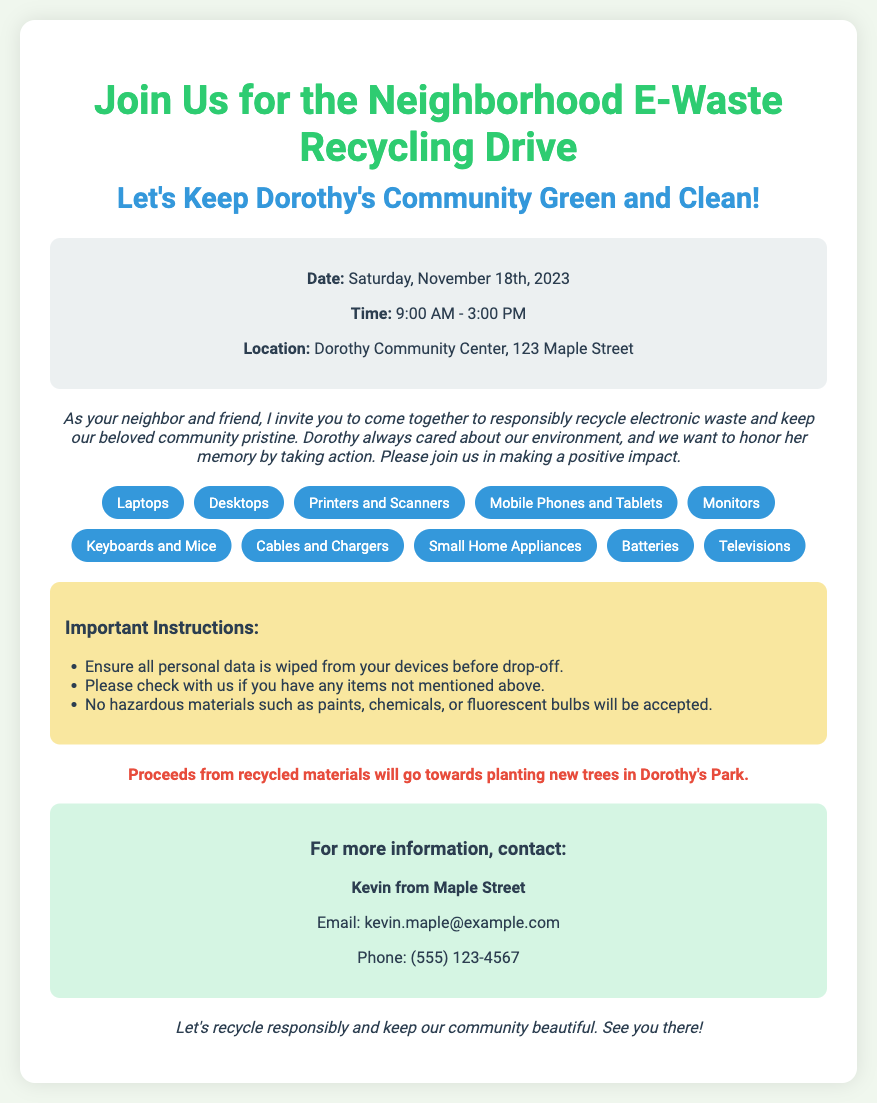what is the date of the recycling drive? The date of the recycling drive is mentioned in the event details section of the document.
Answer: Saturday, November 18th, 2023 what are the hours for the recycling drive? The hours for the recycling drive are stated in the event details section.
Answer: 9:00 AM - 3:00 PM where is the recycling drive taking place? The location of the recycling drive is provided in the event details section.
Answer: Dorothy Community Center, 123 Maple Street who should I contact for more information? The contact person for more information is stated in the contact info section of the document.
Answer: Kevin from Maple Street what items are accepted for recycling? The accepted items are listed in the items accepted section of the document.
Answer: Laptops, Desktops, Printers and Scanners, Mobile Phones and Tablets, Monitors, Keyboards and Mice, Cables and Chargers, Small Home Appliances, Batteries, Televisions what is a special note mentioned in the document? A special note about the proceeds is included in the document and it can be found in the special note section.
Answer: Proceeds from recycled materials will go towards planting new trees in Dorothy's Park why should personal data be wiped from devices? This instruction is included for the safety of participants and the integrity of their data.
Answer: To protect personal data what should I do if I have items not mentioned in the acceptance list? This guidance is given in the instructions section of the document for clarity on unlisted items.
Answer: Please check with us if you have any items not mentioned above what kind of materials are not accepted? The document specifies hazardous materials that will not be accepted in the instructions section.
Answer: No hazardous materials such as paints, chemicals, or fluorescent bulbs will be accepted 